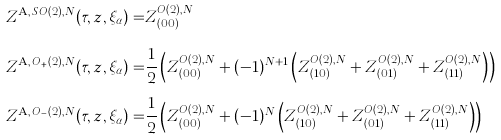<formula> <loc_0><loc_0><loc_500><loc_500>Z ^ { \text {A} , \, S O ( 2 ) , N } ( \tau , z , \xi _ { \alpha } ) = & Z ^ { O ( 2 ) , N } _ { ( 0 0 ) } \\ Z ^ { \text {A} , \, O _ { + } ( 2 ) , N } ( \tau , z , \xi _ { \alpha } ) = & \frac { 1 } { 2 } \left ( Z ^ { O ( 2 ) , N } _ { ( 0 0 ) } + ( - 1 ) ^ { N + 1 } \left ( Z ^ { O ( 2 ) , N } _ { ( 1 0 ) } + Z ^ { O ( 2 ) , N } _ { ( 0 1 ) } + Z ^ { O ( 2 ) , N } _ { ( 1 1 ) } \right ) \right ) \\ Z ^ { \text {A} , \, O _ { - } ( 2 ) , N } ( \tau , z , \xi _ { \alpha } ) = & \frac { 1 } { 2 } \left ( Z ^ { O ( 2 ) , N } _ { ( 0 0 ) } + ( - 1 ) ^ { N } \left ( Z ^ { O ( 2 ) , N } _ { ( 1 0 ) } + Z ^ { O ( 2 ) , N } _ { ( 0 1 ) } + Z ^ { O ( 2 ) , N } _ { ( 1 1 ) } \right ) \right )</formula> 